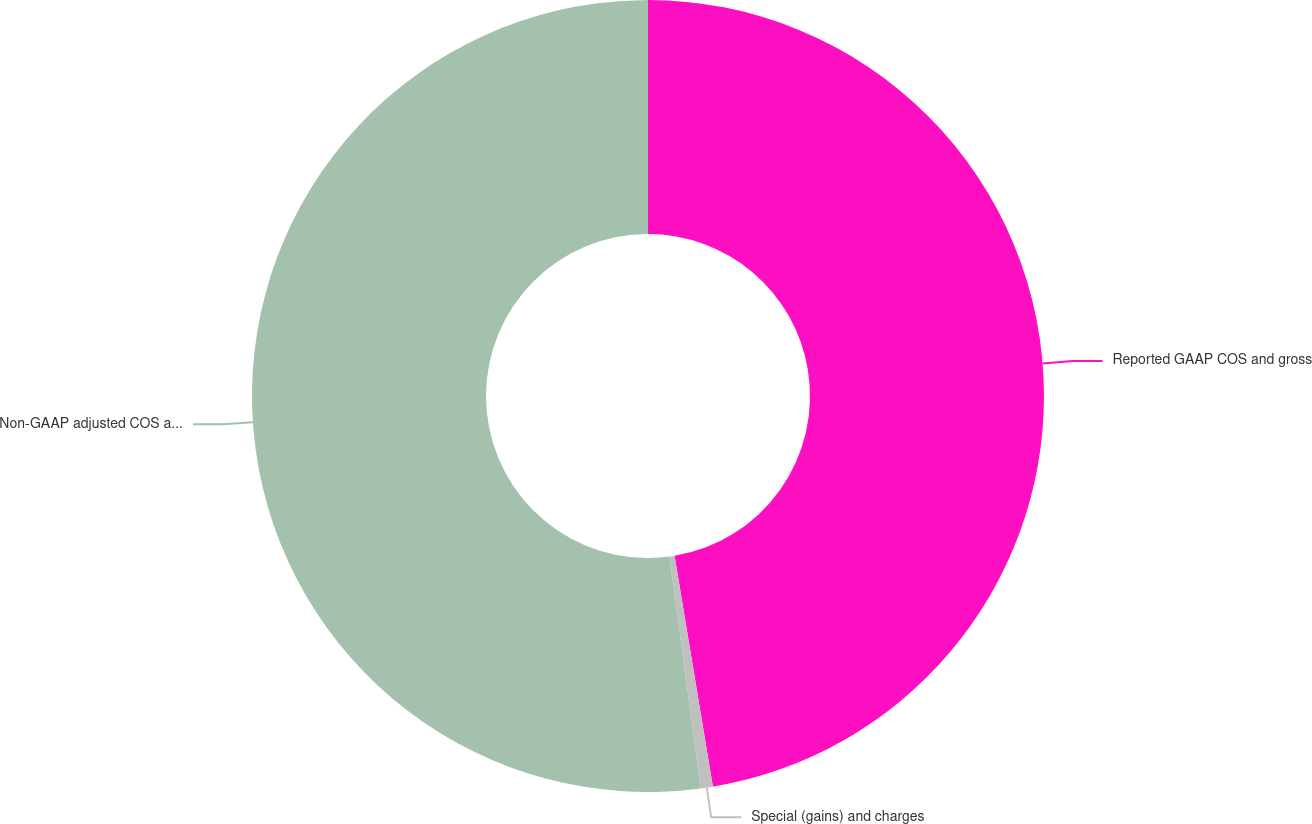<chart> <loc_0><loc_0><loc_500><loc_500><pie_chart><fcel>Reported GAAP COS and gross<fcel>Special (gains) and charges<fcel>Non-GAAP adjusted COS and<nl><fcel>47.38%<fcel>0.5%<fcel>52.12%<nl></chart> 